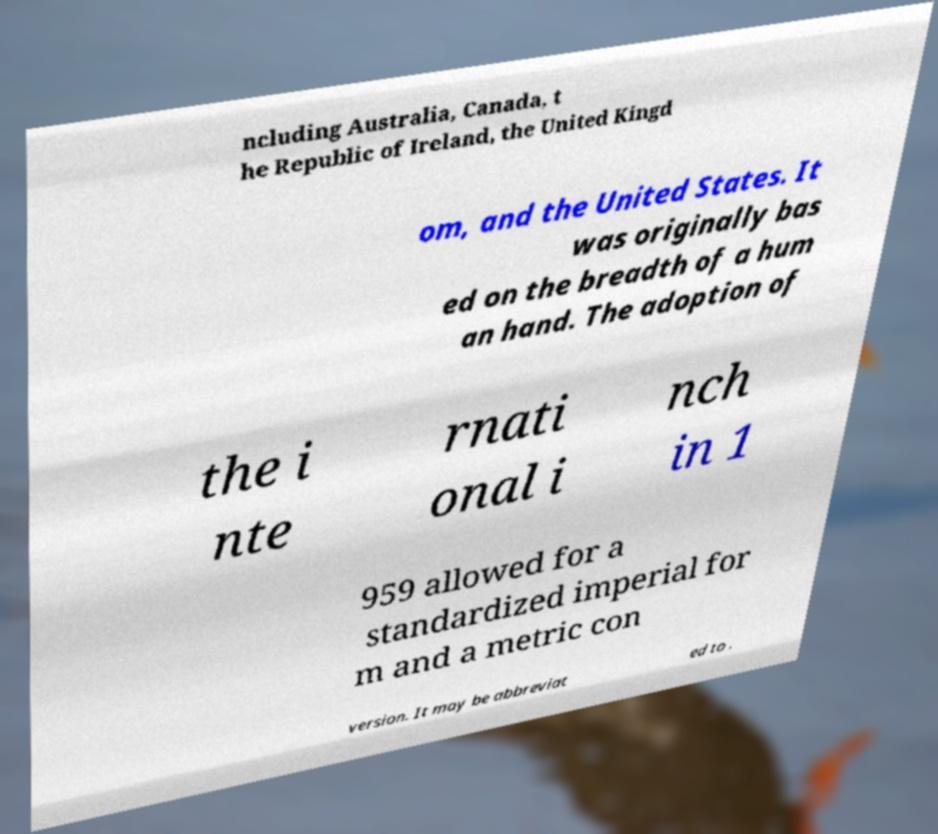Could you extract and type out the text from this image? ncluding Australia, Canada, t he Republic of Ireland, the United Kingd om, and the United States. It was originally bas ed on the breadth of a hum an hand. The adoption of the i nte rnati onal i nch in 1 959 allowed for a standardized imperial for m and a metric con version. It may be abbreviat ed to . 